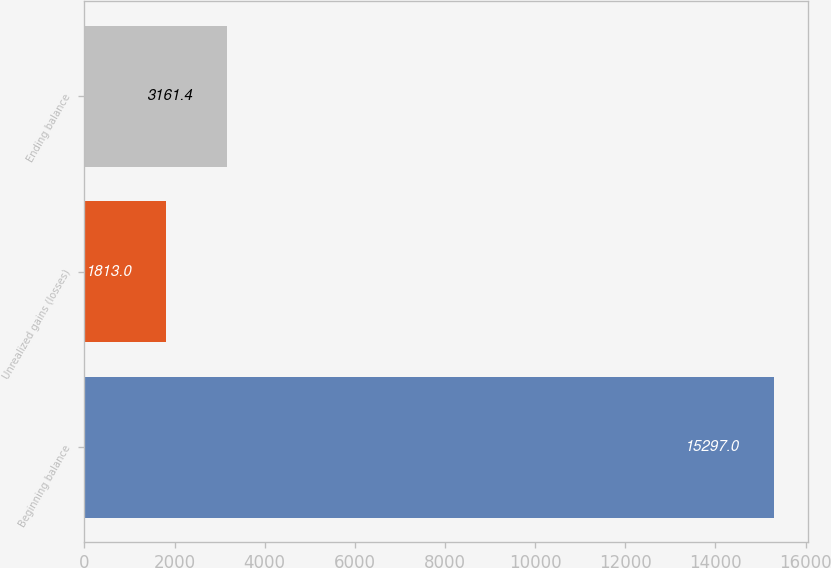<chart> <loc_0><loc_0><loc_500><loc_500><bar_chart><fcel>Beginning balance<fcel>Unrealized gains (losses)<fcel>Ending balance<nl><fcel>15297<fcel>1813<fcel>3161.4<nl></chart> 